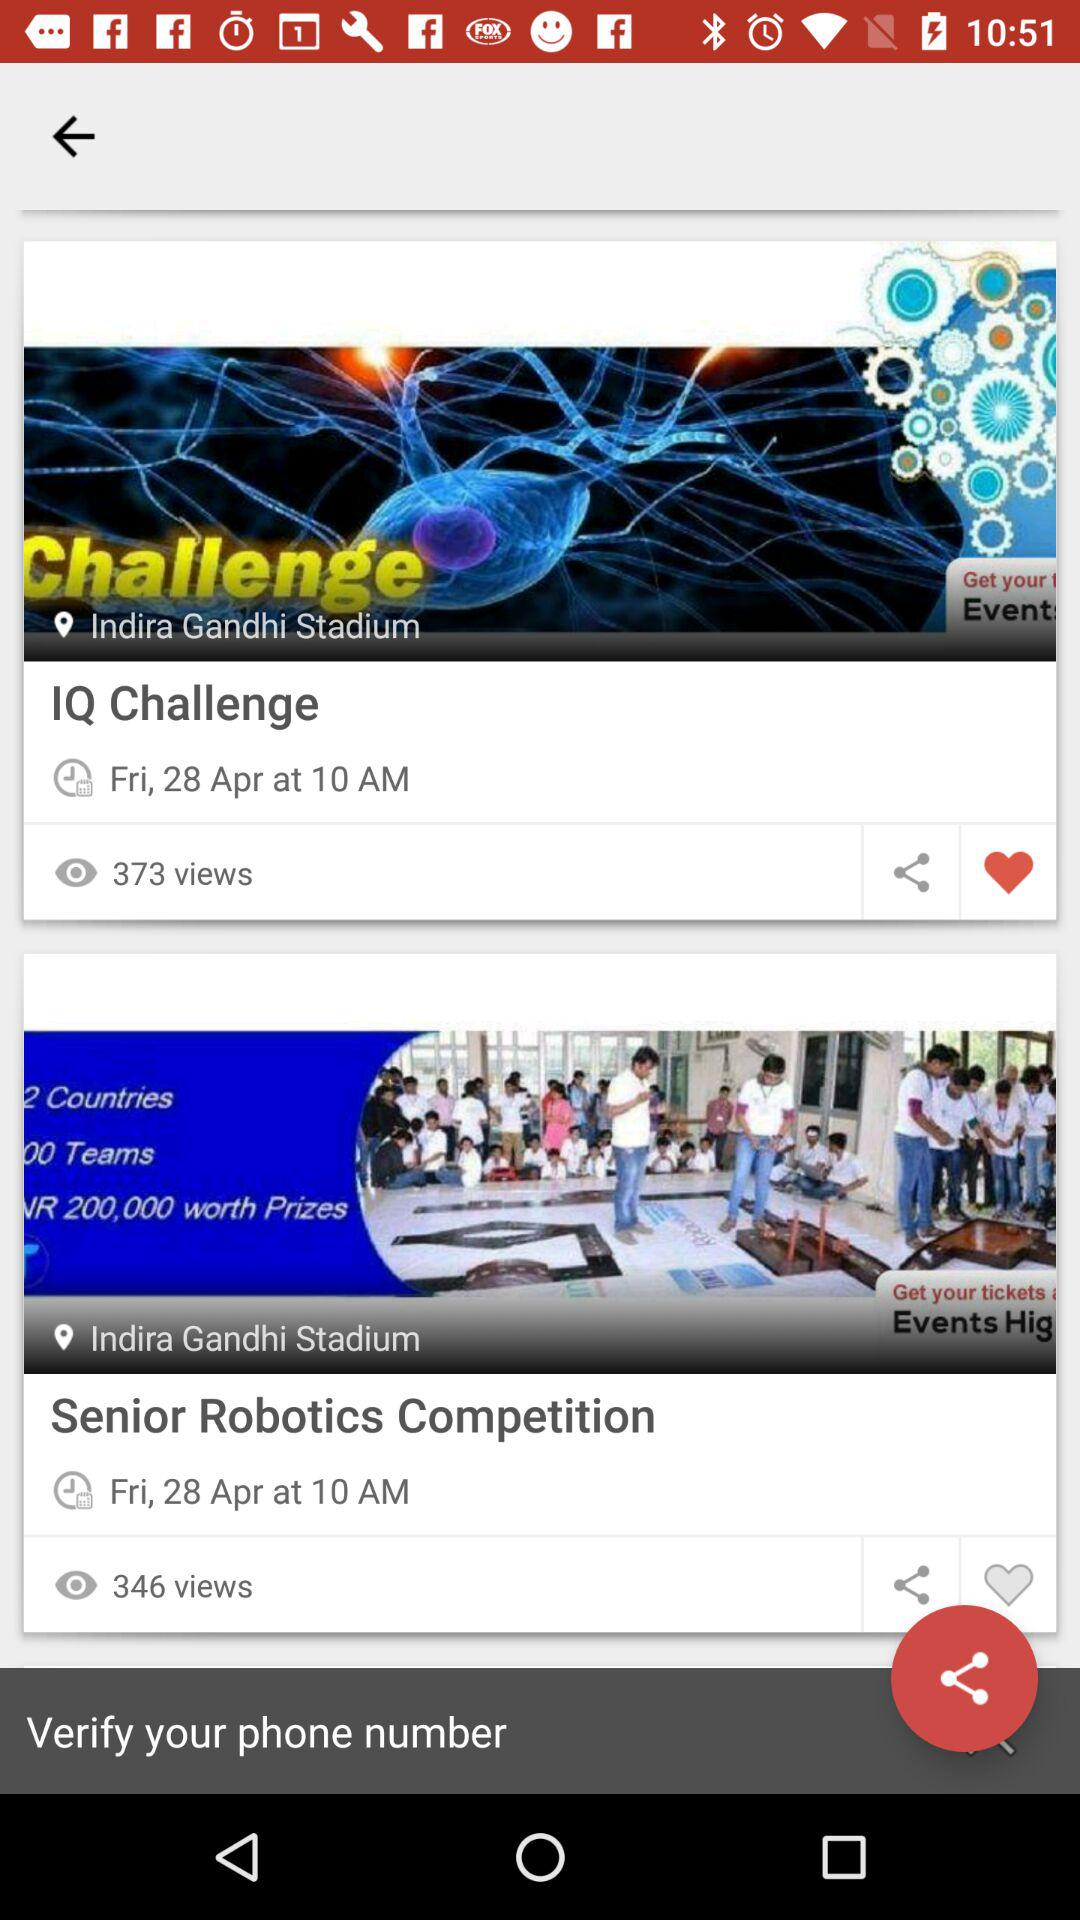How many views are there for the "IQ Challenge"? There are 373 views. 